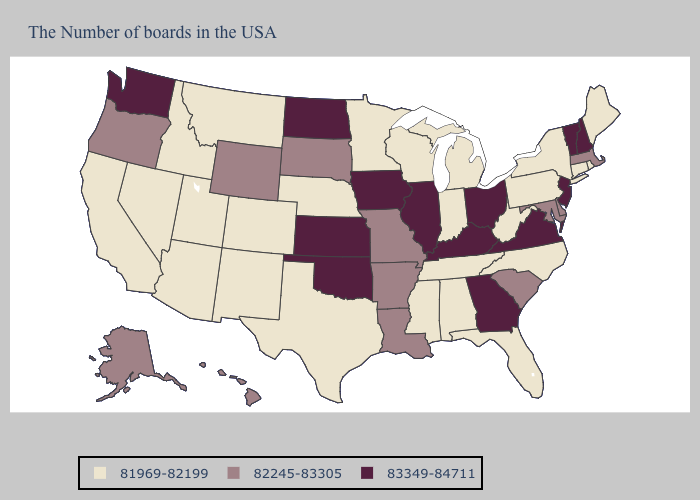Does Hawaii have a higher value than Kentucky?
Write a very short answer. No. Does Iowa have the highest value in the USA?
Keep it brief. Yes. What is the value of North Dakota?
Concise answer only. 83349-84711. What is the value of Oklahoma?
Write a very short answer. 83349-84711. Does Tennessee have the lowest value in the USA?
Answer briefly. Yes. What is the value of New Hampshire?
Give a very brief answer. 83349-84711. What is the value of Texas?
Short answer required. 81969-82199. Does Maryland have the highest value in the South?
Keep it brief. No. Name the states that have a value in the range 83349-84711?
Be succinct. New Hampshire, Vermont, New Jersey, Virginia, Ohio, Georgia, Kentucky, Illinois, Iowa, Kansas, Oklahoma, North Dakota, Washington. Which states have the lowest value in the USA?
Concise answer only. Maine, Rhode Island, Connecticut, New York, Pennsylvania, North Carolina, West Virginia, Florida, Michigan, Indiana, Alabama, Tennessee, Wisconsin, Mississippi, Minnesota, Nebraska, Texas, Colorado, New Mexico, Utah, Montana, Arizona, Idaho, Nevada, California. Among the states that border Montana , does North Dakota have the highest value?
Give a very brief answer. Yes. Which states hav the highest value in the MidWest?
Short answer required. Ohio, Illinois, Iowa, Kansas, North Dakota. Among the states that border North Dakota , does South Dakota have the highest value?
Answer briefly. Yes. What is the highest value in the USA?
Quick response, please. 83349-84711. Name the states that have a value in the range 82245-83305?
Concise answer only. Massachusetts, Delaware, Maryland, South Carolina, Louisiana, Missouri, Arkansas, South Dakota, Wyoming, Oregon, Alaska, Hawaii. 